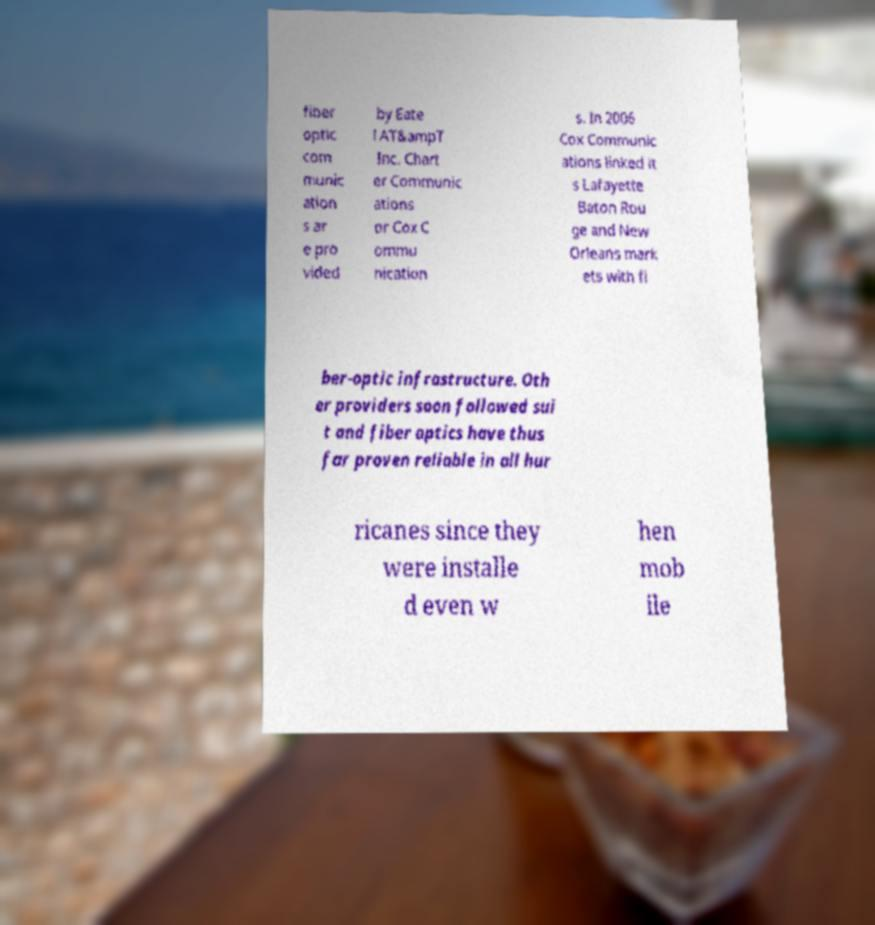For documentation purposes, I need the text within this image transcribed. Could you provide that? fiber optic com munic ation s ar e pro vided by Eate l AT&ampT Inc. Chart er Communic ations or Cox C ommu nication s. In 2006 Cox Communic ations linked it s Lafayette Baton Rou ge and New Orleans mark ets with fi ber-optic infrastructure. Oth er providers soon followed sui t and fiber optics have thus far proven reliable in all hur ricanes since they were installe d even w hen mob ile 